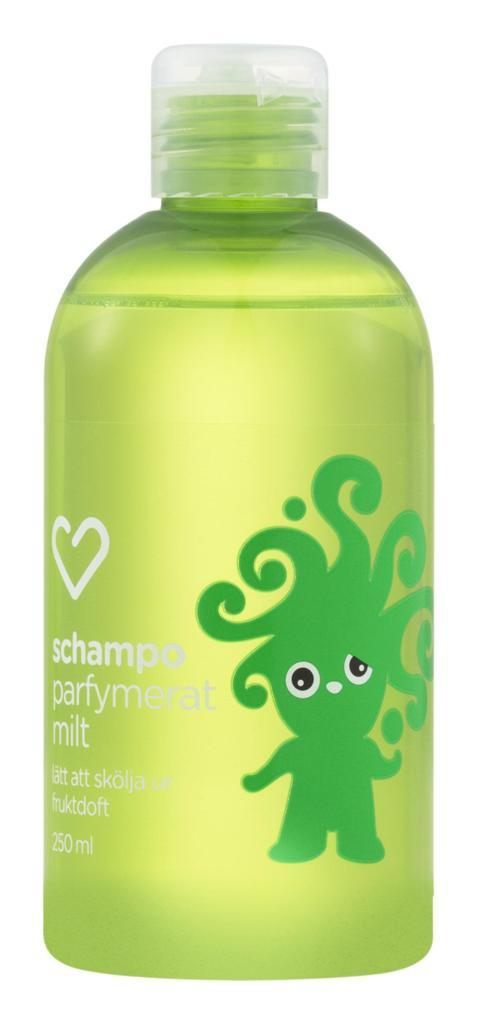<image>
Give a short and clear explanation of the subsequent image. A bottle of schampo parfymerat milt has a green troll-like figure on it. 